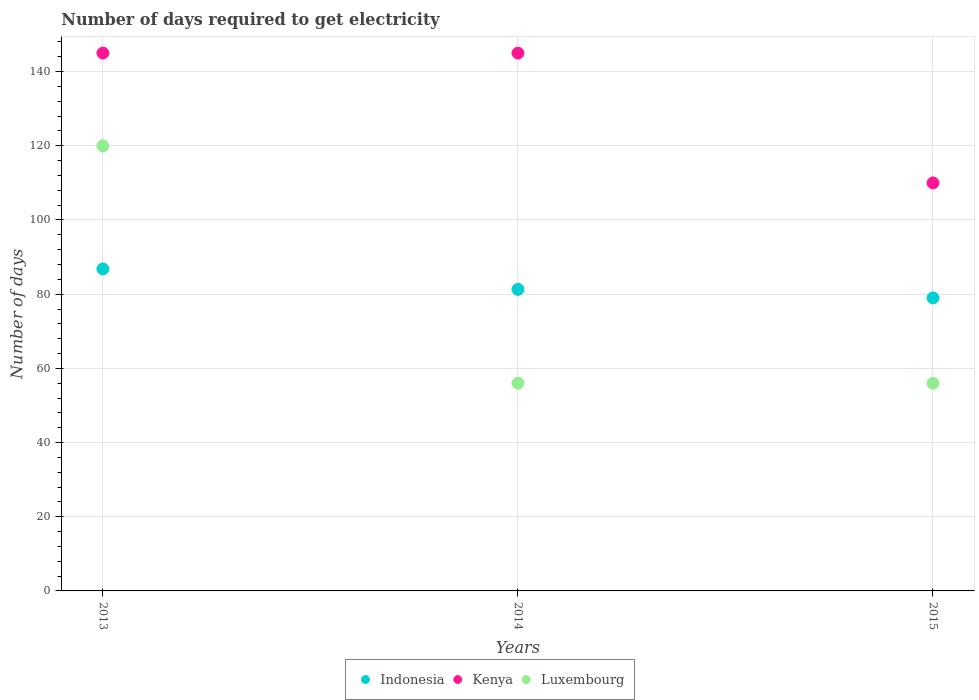What is the number of days required to get electricity in in Indonesia in 2013?
Your answer should be very brief. 86.8. Across all years, what is the maximum number of days required to get electricity in in Indonesia?
Provide a succinct answer. 86.8. Across all years, what is the minimum number of days required to get electricity in in Indonesia?
Provide a short and direct response. 79. What is the total number of days required to get electricity in in Luxembourg in the graph?
Your answer should be compact. 232. What is the difference between the number of days required to get electricity in in Luxembourg in 2013 and that in 2015?
Provide a short and direct response. 64. What is the difference between the number of days required to get electricity in in Luxembourg in 2013 and the number of days required to get electricity in in Indonesia in 2014?
Provide a short and direct response. 38.7. What is the average number of days required to get electricity in in Kenya per year?
Your answer should be very brief. 133.33. In the year 2014, what is the difference between the number of days required to get electricity in in Kenya and number of days required to get electricity in in Indonesia?
Give a very brief answer. 63.7. What is the ratio of the number of days required to get electricity in in Luxembourg in 2013 to that in 2015?
Ensure brevity in your answer.  2.14. Is the difference between the number of days required to get electricity in in Kenya in 2013 and 2015 greater than the difference between the number of days required to get electricity in in Indonesia in 2013 and 2015?
Give a very brief answer. Yes. What is the difference between the highest and the second highest number of days required to get electricity in in Luxembourg?
Your answer should be very brief. 64. What is the difference between the highest and the lowest number of days required to get electricity in in Luxembourg?
Offer a very short reply. 64. Is the number of days required to get electricity in in Indonesia strictly greater than the number of days required to get electricity in in Luxembourg over the years?
Your response must be concise. No. How many dotlines are there?
Ensure brevity in your answer.  3. How many years are there in the graph?
Your answer should be compact. 3. What is the difference between two consecutive major ticks on the Y-axis?
Your answer should be very brief. 20. Are the values on the major ticks of Y-axis written in scientific E-notation?
Your answer should be very brief. No. Does the graph contain any zero values?
Provide a short and direct response. No. How are the legend labels stacked?
Provide a succinct answer. Horizontal. What is the title of the graph?
Keep it short and to the point. Number of days required to get electricity. What is the label or title of the X-axis?
Provide a short and direct response. Years. What is the label or title of the Y-axis?
Keep it short and to the point. Number of days. What is the Number of days in Indonesia in 2013?
Ensure brevity in your answer.  86.8. What is the Number of days in Kenya in 2013?
Offer a very short reply. 145. What is the Number of days of Luxembourg in 2013?
Provide a succinct answer. 120. What is the Number of days of Indonesia in 2014?
Ensure brevity in your answer.  81.3. What is the Number of days of Kenya in 2014?
Provide a succinct answer. 145. What is the Number of days of Luxembourg in 2014?
Keep it short and to the point. 56. What is the Number of days of Indonesia in 2015?
Make the answer very short. 79. What is the Number of days of Kenya in 2015?
Your response must be concise. 110. Across all years, what is the maximum Number of days in Indonesia?
Your answer should be compact. 86.8. Across all years, what is the maximum Number of days of Kenya?
Ensure brevity in your answer.  145. Across all years, what is the maximum Number of days in Luxembourg?
Make the answer very short. 120. Across all years, what is the minimum Number of days in Indonesia?
Offer a very short reply. 79. Across all years, what is the minimum Number of days in Kenya?
Your answer should be compact. 110. What is the total Number of days in Indonesia in the graph?
Provide a succinct answer. 247.1. What is the total Number of days in Luxembourg in the graph?
Offer a very short reply. 232. What is the difference between the Number of days of Indonesia in 2013 and that in 2014?
Offer a terse response. 5.5. What is the difference between the Number of days of Luxembourg in 2013 and that in 2014?
Give a very brief answer. 64. What is the difference between the Number of days of Luxembourg in 2013 and that in 2015?
Make the answer very short. 64. What is the difference between the Number of days of Indonesia in 2014 and that in 2015?
Keep it short and to the point. 2.3. What is the difference between the Number of days of Indonesia in 2013 and the Number of days of Kenya in 2014?
Make the answer very short. -58.2. What is the difference between the Number of days of Indonesia in 2013 and the Number of days of Luxembourg in 2014?
Provide a succinct answer. 30.8. What is the difference between the Number of days of Kenya in 2013 and the Number of days of Luxembourg in 2014?
Make the answer very short. 89. What is the difference between the Number of days in Indonesia in 2013 and the Number of days in Kenya in 2015?
Provide a succinct answer. -23.2. What is the difference between the Number of days of Indonesia in 2013 and the Number of days of Luxembourg in 2015?
Provide a succinct answer. 30.8. What is the difference between the Number of days of Kenya in 2013 and the Number of days of Luxembourg in 2015?
Your response must be concise. 89. What is the difference between the Number of days in Indonesia in 2014 and the Number of days in Kenya in 2015?
Your answer should be compact. -28.7. What is the difference between the Number of days in Indonesia in 2014 and the Number of days in Luxembourg in 2015?
Ensure brevity in your answer.  25.3. What is the difference between the Number of days of Kenya in 2014 and the Number of days of Luxembourg in 2015?
Keep it short and to the point. 89. What is the average Number of days of Indonesia per year?
Offer a very short reply. 82.37. What is the average Number of days in Kenya per year?
Offer a terse response. 133.33. What is the average Number of days of Luxembourg per year?
Offer a very short reply. 77.33. In the year 2013, what is the difference between the Number of days in Indonesia and Number of days in Kenya?
Offer a terse response. -58.2. In the year 2013, what is the difference between the Number of days of Indonesia and Number of days of Luxembourg?
Give a very brief answer. -33.2. In the year 2014, what is the difference between the Number of days of Indonesia and Number of days of Kenya?
Offer a very short reply. -63.7. In the year 2014, what is the difference between the Number of days in Indonesia and Number of days in Luxembourg?
Your response must be concise. 25.3. In the year 2014, what is the difference between the Number of days of Kenya and Number of days of Luxembourg?
Provide a succinct answer. 89. In the year 2015, what is the difference between the Number of days of Indonesia and Number of days of Kenya?
Offer a very short reply. -31. In the year 2015, what is the difference between the Number of days in Indonesia and Number of days in Luxembourg?
Make the answer very short. 23. What is the ratio of the Number of days in Indonesia in 2013 to that in 2014?
Offer a terse response. 1.07. What is the ratio of the Number of days of Luxembourg in 2013 to that in 2014?
Provide a succinct answer. 2.14. What is the ratio of the Number of days in Indonesia in 2013 to that in 2015?
Provide a short and direct response. 1.1. What is the ratio of the Number of days of Kenya in 2013 to that in 2015?
Provide a short and direct response. 1.32. What is the ratio of the Number of days of Luxembourg in 2013 to that in 2015?
Provide a short and direct response. 2.14. What is the ratio of the Number of days of Indonesia in 2014 to that in 2015?
Provide a succinct answer. 1.03. What is the ratio of the Number of days in Kenya in 2014 to that in 2015?
Offer a very short reply. 1.32. What is the ratio of the Number of days of Luxembourg in 2014 to that in 2015?
Keep it short and to the point. 1. What is the difference between the highest and the second highest Number of days of Kenya?
Your answer should be very brief. 0. What is the difference between the highest and the second highest Number of days in Luxembourg?
Give a very brief answer. 64. 